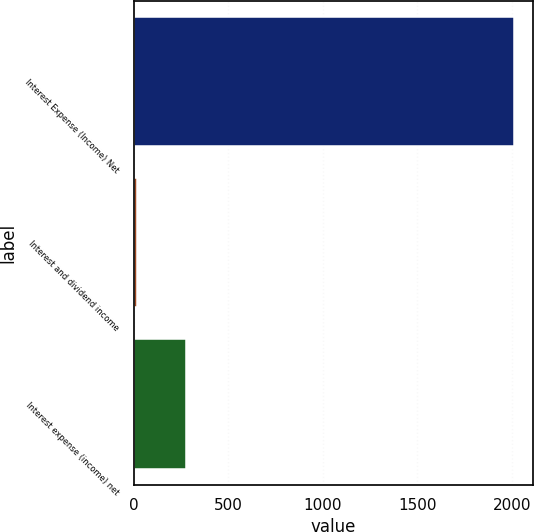Convert chart to OTSL. <chart><loc_0><loc_0><loc_500><loc_500><bar_chart><fcel>Interest Expense (Income) Net<fcel>Interest and dividend income<fcel>Interest expense (income) net<nl><fcel>2013<fcel>21<fcel>278<nl></chart> 